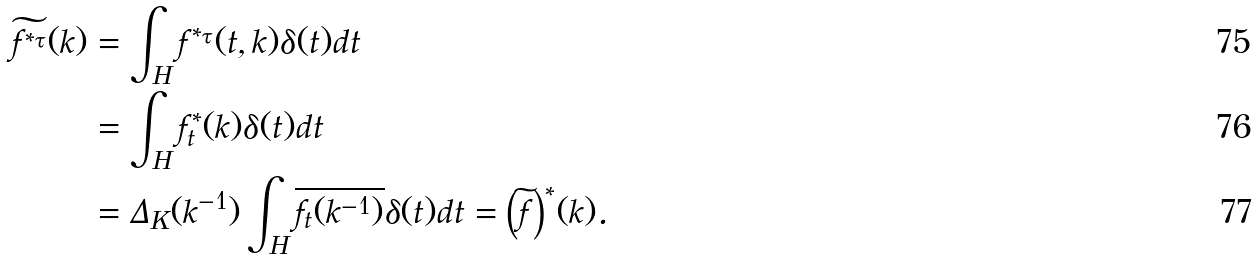<formula> <loc_0><loc_0><loc_500><loc_500>\widetilde { f ^ { * _ { \tau } } } ( k ) & = \int _ { H } f ^ { * _ { \tau } } ( t , k ) \delta ( t ) d t \\ & = \int _ { H } f _ { t } ^ { * } ( k ) \delta ( t ) d t \\ & = \Delta _ { K } ( k ^ { - 1 } ) \int _ { H } \overline { f _ { t } ( k ^ { - 1 } ) } \delta ( t ) d t = { \left ( \widetilde { f } \right ) } ^ { * } ( k ) .</formula> 